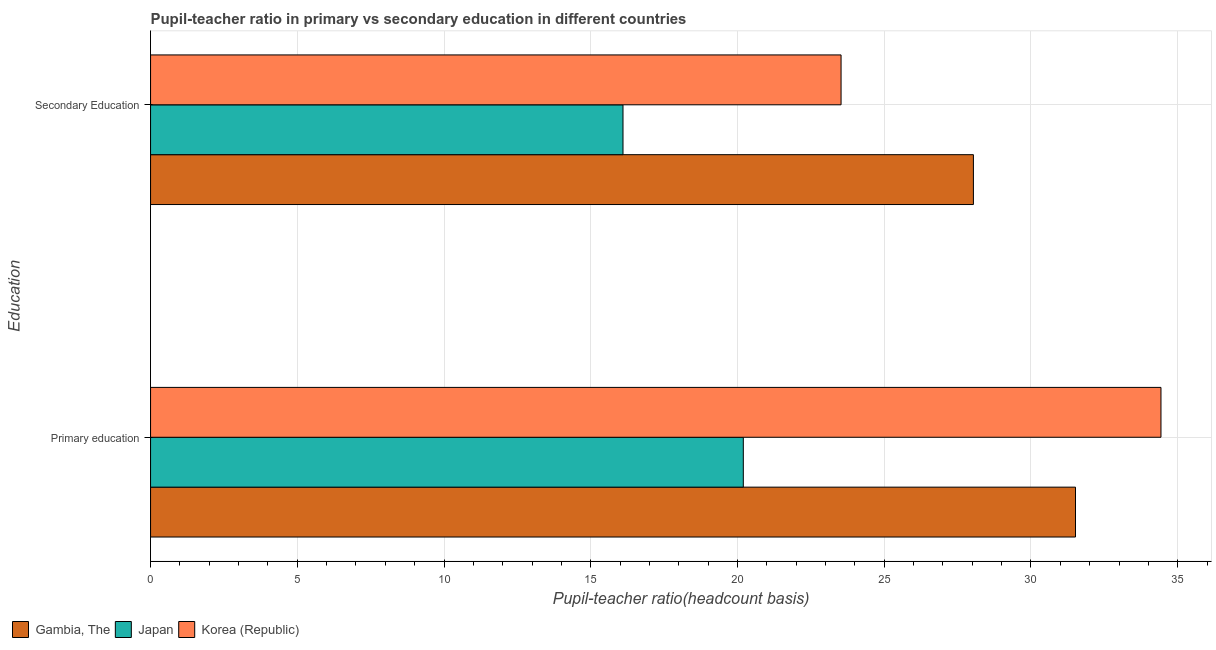How many different coloured bars are there?
Make the answer very short. 3. How many groups of bars are there?
Your answer should be very brief. 2. Are the number of bars on each tick of the Y-axis equal?
Offer a terse response. Yes. How many bars are there on the 2nd tick from the bottom?
Your response must be concise. 3. What is the pupil-teacher ratio in primary education in Korea (Republic)?
Your response must be concise. 34.43. Across all countries, what is the maximum pupil teacher ratio on secondary education?
Offer a terse response. 28.04. Across all countries, what is the minimum pupil-teacher ratio in primary education?
Your answer should be compact. 20.2. In which country was the pupil teacher ratio on secondary education maximum?
Offer a terse response. Gambia, The. In which country was the pupil teacher ratio on secondary education minimum?
Your response must be concise. Japan. What is the total pupil teacher ratio on secondary education in the graph?
Keep it short and to the point. 67.67. What is the difference between the pupil-teacher ratio in primary education in Korea (Republic) and that in Gambia, The?
Your answer should be very brief. 2.91. What is the difference between the pupil teacher ratio on secondary education in Japan and the pupil-teacher ratio in primary education in Korea (Republic)?
Provide a succinct answer. -18.33. What is the average pupil teacher ratio on secondary education per country?
Offer a terse response. 22.56. What is the difference between the pupil teacher ratio on secondary education and pupil-teacher ratio in primary education in Korea (Republic)?
Ensure brevity in your answer.  -10.9. What is the ratio of the pupil teacher ratio on secondary education in Japan to that in Gambia, The?
Give a very brief answer. 0.57. In how many countries, is the pupil teacher ratio on secondary education greater than the average pupil teacher ratio on secondary education taken over all countries?
Your response must be concise. 2. What does the 3rd bar from the top in Secondary Education represents?
Keep it short and to the point. Gambia, The. Are all the bars in the graph horizontal?
Ensure brevity in your answer.  Yes. How many countries are there in the graph?
Your response must be concise. 3. Are the values on the major ticks of X-axis written in scientific E-notation?
Keep it short and to the point. No. Does the graph contain any zero values?
Make the answer very short. No. Does the graph contain grids?
Offer a very short reply. Yes. What is the title of the graph?
Provide a short and direct response. Pupil-teacher ratio in primary vs secondary education in different countries. What is the label or title of the X-axis?
Your answer should be compact. Pupil-teacher ratio(headcount basis). What is the label or title of the Y-axis?
Offer a terse response. Education. What is the Pupil-teacher ratio(headcount basis) in Gambia, The in Primary education?
Your response must be concise. 31.52. What is the Pupil-teacher ratio(headcount basis) of Japan in Primary education?
Give a very brief answer. 20.2. What is the Pupil-teacher ratio(headcount basis) in Korea (Republic) in Primary education?
Offer a terse response. 34.43. What is the Pupil-teacher ratio(headcount basis) of Gambia, The in Secondary Education?
Your answer should be very brief. 28.04. What is the Pupil-teacher ratio(headcount basis) in Japan in Secondary Education?
Ensure brevity in your answer.  16.1. What is the Pupil-teacher ratio(headcount basis) of Korea (Republic) in Secondary Education?
Your answer should be compact. 23.53. Across all Education, what is the maximum Pupil-teacher ratio(headcount basis) of Gambia, The?
Provide a succinct answer. 31.52. Across all Education, what is the maximum Pupil-teacher ratio(headcount basis) of Japan?
Ensure brevity in your answer.  20.2. Across all Education, what is the maximum Pupil-teacher ratio(headcount basis) of Korea (Republic)?
Your answer should be compact. 34.43. Across all Education, what is the minimum Pupil-teacher ratio(headcount basis) in Gambia, The?
Make the answer very short. 28.04. Across all Education, what is the minimum Pupil-teacher ratio(headcount basis) of Japan?
Keep it short and to the point. 16.1. Across all Education, what is the minimum Pupil-teacher ratio(headcount basis) of Korea (Republic)?
Your answer should be compact. 23.53. What is the total Pupil-teacher ratio(headcount basis) of Gambia, The in the graph?
Your answer should be very brief. 59.56. What is the total Pupil-teacher ratio(headcount basis) of Japan in the graph?
Ensure brevity in your answer.  36.3. What is the total Pupil-teacher ratio(headcount basis) in Korea (Republic) in the graph?
Keep it short and to the point. 57.96. What is the difference between the Pupil-teacher ratio(headcount basis) in Gambia, The in Primary education and that in Secondary Education?
Your response must be concise. 3.48. What is the difference between the Pupil-teacher ratio(headcount basis) of Japan in Primary education and that in Secondary Education?
Your response must be concise. 4.1. What is the difference between the Pupil-teacher ratio(headcount basis) in Korea (Republic) in Primary education and that in Secondary Education?
Your response must be concise. 10.9. What is the difference between the Pupil-teacher ratio(headcount basis) in Gambia, The in Primary education and the Pupil-teacher ratio(headcount basis) in Japan in Secondary Education?
Your answer should be very brief. 15.42. What is the difference between the Pupil-teacher ratio(headcount basis) in Gambia, The in Primary education and the Pupil-teacher ratio(headcount basis) in Korea (Republic) in Secondary Education?
Give a very brief answer. 7.99. What is the difference between the Pupil-teacher ratio(headcount basis) of Japan in Primary education and the Pupil-teacher ratio(headcount basis) of Korea (Republic) in Secondary Education?
Your answer should be compact. -3.33. What is the average Pupil-teacher ratio(headcount basis) in Gambia, The per Education?
Ensure brevity in your answer.  29.78. What is the average Pupil-teacher ratio(headcount basis) in Japan per Education?
Give a very brief answer. 18.15. What is the average Pupil-teacher ratio(headcount basis) of Korea (Republic) per Education?
Make the answer very short. 28.98. What is the difference between the Pupil-teacher ratio(headcount basis) of Gambia, The and Pupil-teacher ratio(headcount basis) of Japan in Primary education?
Keep it short and to the point. 11.32. What is the difference between the Pupil-teacher ratio(headcount basis) of Gambia, The and Pupil-teacher ratio(headcount basis) of Korea (Republic) in Primary education?
Offer a very short reply. -2.91. What is the difference between the Pupil-teacher ratio(headcount basis) of Japan and Pupil-teacher ratio(headcount basis) of Korea (Republic) in Primary education?
Provide a short and direct response. -14.23. What is the difference between the Pupil-teacher ratio(headcount basis) of Gambia, The and Pupil-teacher ratio(headcount basis) of Japan in Secondary Education?
Provide a succinct answer. 11.94. What is the difference between the Pupil-teacher ratio(headcount basis) of Gambia, The and Pupil-teacher ratio(headcount basis) of Korea (Republic) in Secondary Education?
Offer a very short reply. 4.51. What is the difference between the Pupil-teacher ratio(headcount basis) in Japan and Pupil-teacher ratio(headcount basis) in Korea (Republic) in Secondary Education?
Offer a terse response. -7.43. What is the ratio of the Pupil-teacher ratio(headcount basis) in Gambia, The in Primary education to that in Secondary Education?
Your answer should be compact. 1.12. What is the ratio of the Pupil-teacher ratio(headcount basis) in Japan in Primary education to that in Secondary Education?
Ensure brevity in your answer.  1.25. What is the ratio of the Pupil-teacher ratio(headcount basis) in Korea (Republic) in Primary education to that in Secondary Education?
Your answer should be very brief. 1.46. What is the difference between the highest and the second highest Pupil-teacher ratio(headcount basis) in Gambia, The?
Offer a very short reply. 3.48. What is the difference between the highest and the second highest Pupil-teacher ratio(headcount basis) of Japan?
Your answer should be very brief. 4.1. What is the difference between the highest and the second highest Pupil-teacher ratio(headcount basis) in Korea (Republic)?
Offer a very short reply. 10.9. What is the difference between the highest and the lowest Pupil-teacher ratio(headcount basis) of Gambia, The?
Your answer should be compact. 3.48. What is the difference between the highest and the lowest Pupil-teacher ratio(headcount basis) in Japan?
Provide a succinct answer. 4.1. What is the difference between the highest and the lowest Pupil-teacher ratio(headcount basis) in Korea (Republic)?
Your response must be concise. 10.9. 